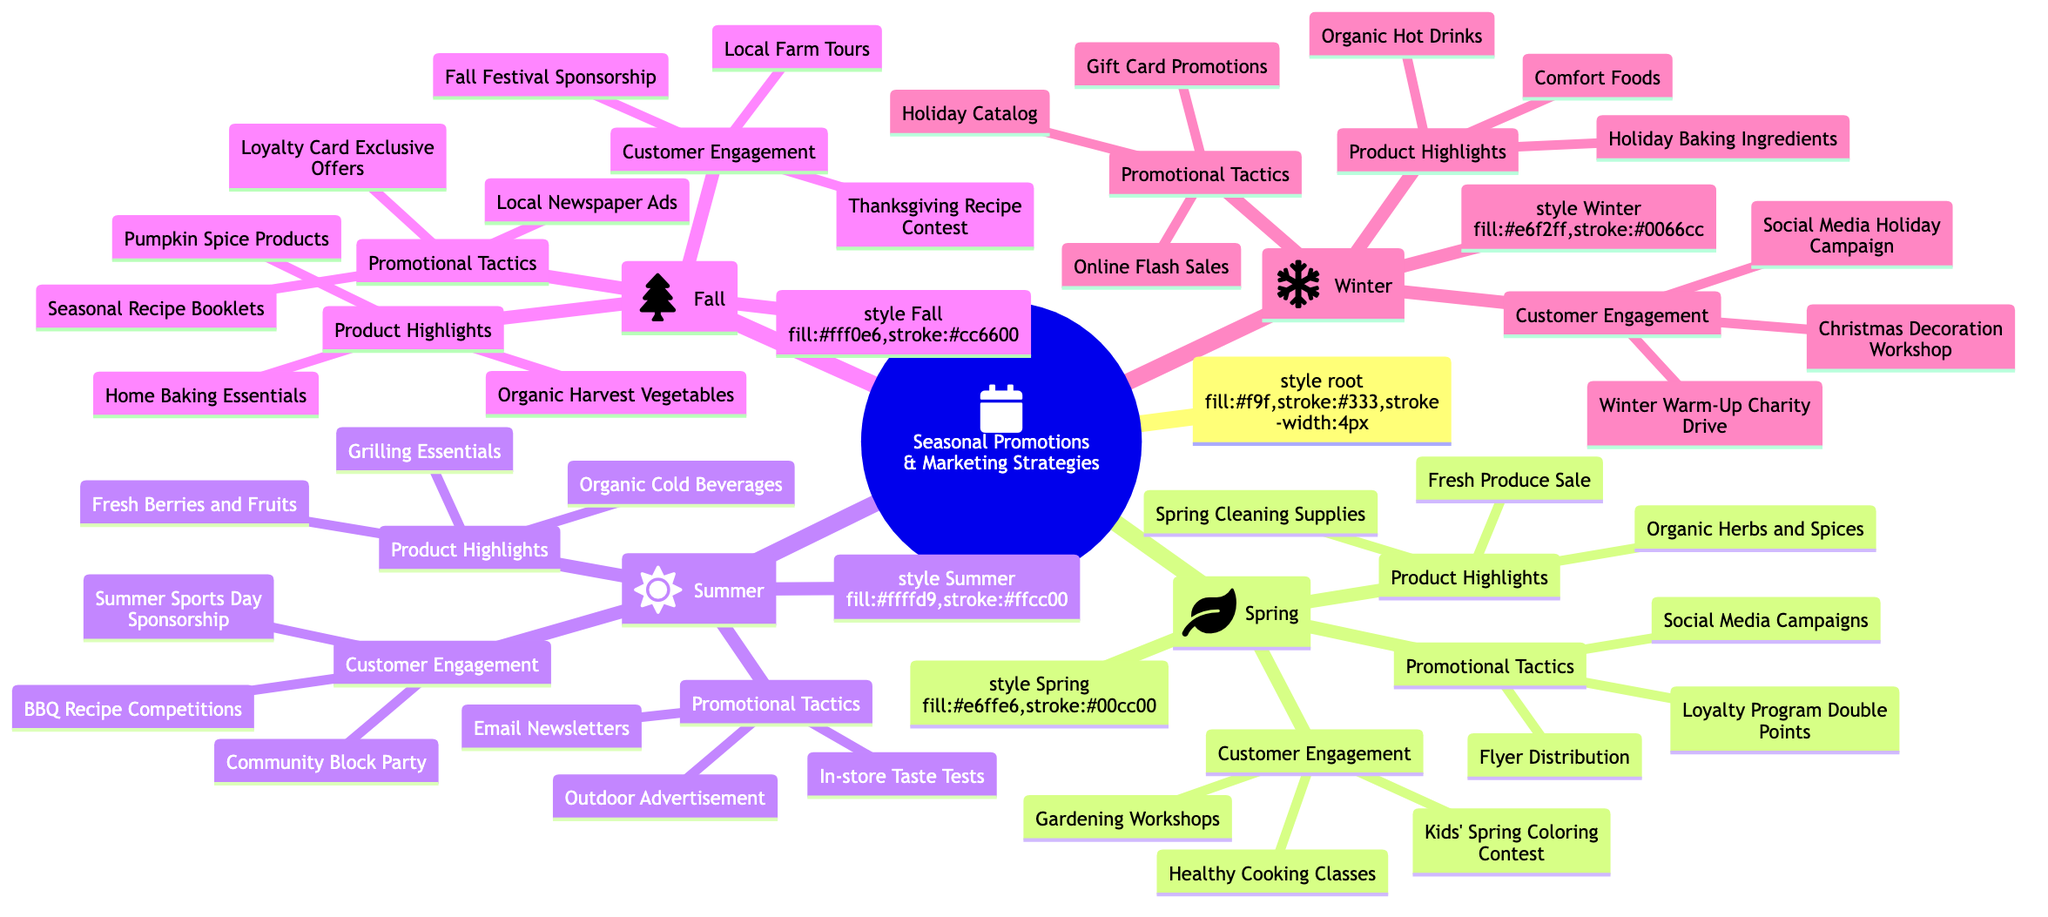What are the Product Highlights for Spring? The diagram shows the section under "Spring" labeled "Product Highlights," which lists three specific items: Fresh Produce Sale, Organic Herbs and Spices, and Spring Cleaning Supplies.
Answer: Fresh Produce Sale, Organic Herbs and Spices, Spring Cleaning Supplies How many Customer Engagement activities are listed for Summer? In the "Summer" section, the "Customer Engagement" category includes three unique activities: BBQ Recipe Competitions, Summer Sports Day Sponsorship, and Community Block Party. Therefore, the total count is three.
Answer: 3 What is one Promotional Tactic for Fall? The "Fall" section includes a list under "Promotional Tactics." One of the listed items is "Loyalty Card Exclusive Offers."
Answer: Loyalty Card Exclusive Offers Which season features Gardening Workshops? Gardening Workshops are included in the "Customer Engagement" section under "Spring," indicating that they are specifically associated with that season.
Answer: Spring Name the Product Highlights for Winter. Under the "Product Highlights" in the "Winter" section, three items are listed: Holiday Baking Ingredients, Comfort Foods, and Organic Hot Drinks.
Answer: Holiday Baking Ingredients, Comfort Foods, Organic Hot Drinks Which season has the most diverse range of Customer Engagement activities based on the diagram? The "Spring," "Summer," "Fall," and "Winter" sections are evaluated, and all four have three activities each. However, "Summer" includes a community event, thereby potentially increasing engagement diversity.
Answer: Summer What promotional tactic is unique to Winter compared to other seasons? The "Holiday Catalog" is mentioned under the "Promotional Tactics" for "Winter," setting it apart as it relates specifically to the holiday season.
Answer: Holiday Catalog What product category is highlighted in both Fall and Winter? Both the "Fall" and "Winter" sections include "Baking" as part of their product highlights, with Fall focusing on Home Baking Essentials and Winter on Holiday Baking Ingredients.
Answer: Baking 